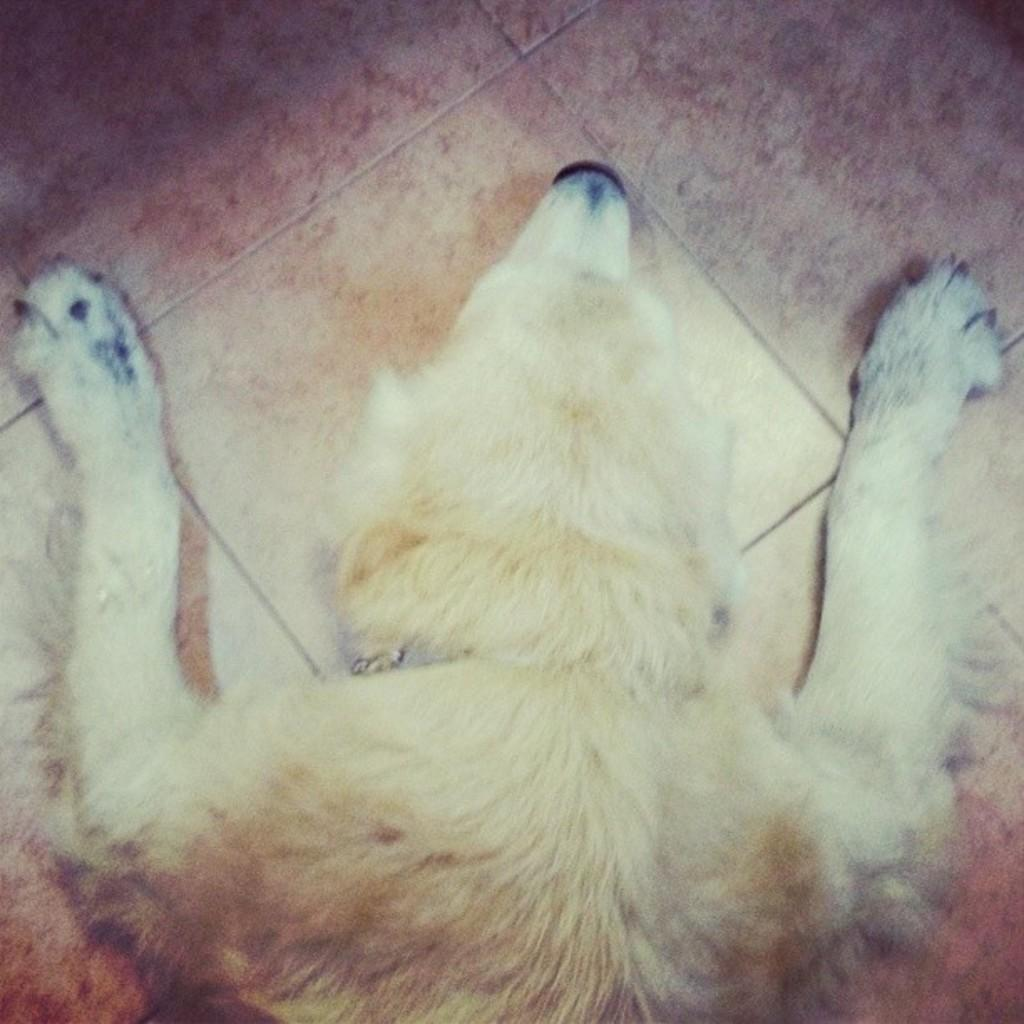What type of animal is in the image? There is a dog in the image. What position is the dog in? The dog is laying on the floor. What color is the dog? The dog is light brown in color. What flavor of cake is the dog eating in the image? There is no cake present in the image; it features a dog laying on the floor. 